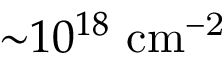Convert formula to latex. <formula><loc_0><loc_0><loc_500><loc_500>{ \sim } 1 0 ^ { 1 8 } c m ^ { - 2 }</formula> 